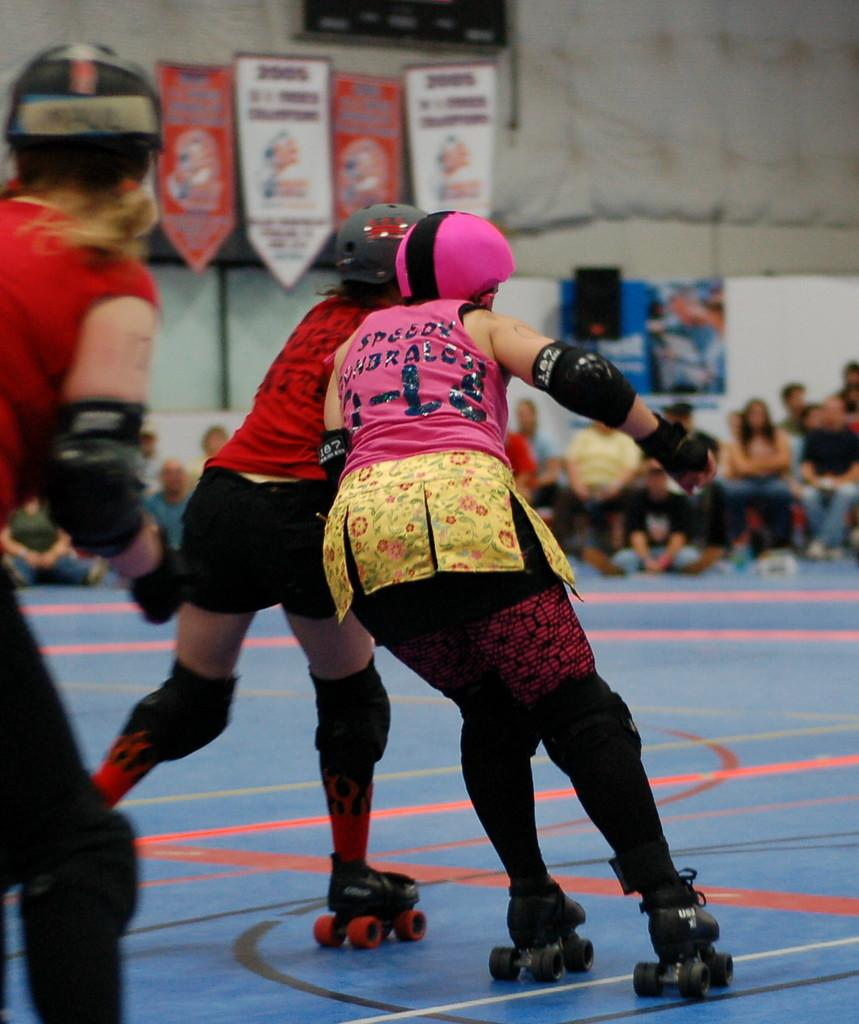What are the people in the image wearing on their feet? The people are wearing skate-wheels in the image. What can be seen on the people's heads in the image? The people in the image are wearing helmets. What is visible in the background of the image? There is a group of people with different color dresses, many boards, and a wall in the background. How are the people sorting the boards in the image? There is no indication in the image that the people are sorting the boards; they are simply visible in the background. 